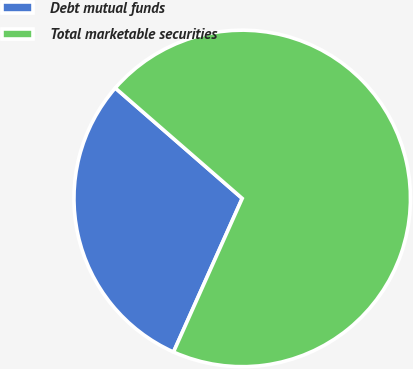<chart> <loc_0><loc_0><loc_500><loc_500><pie_chart><fcel>Debt mutual funds<fcel>Total marketable securities<nl><fcel>29.7%<fcel>70.3%<nl></chart> 